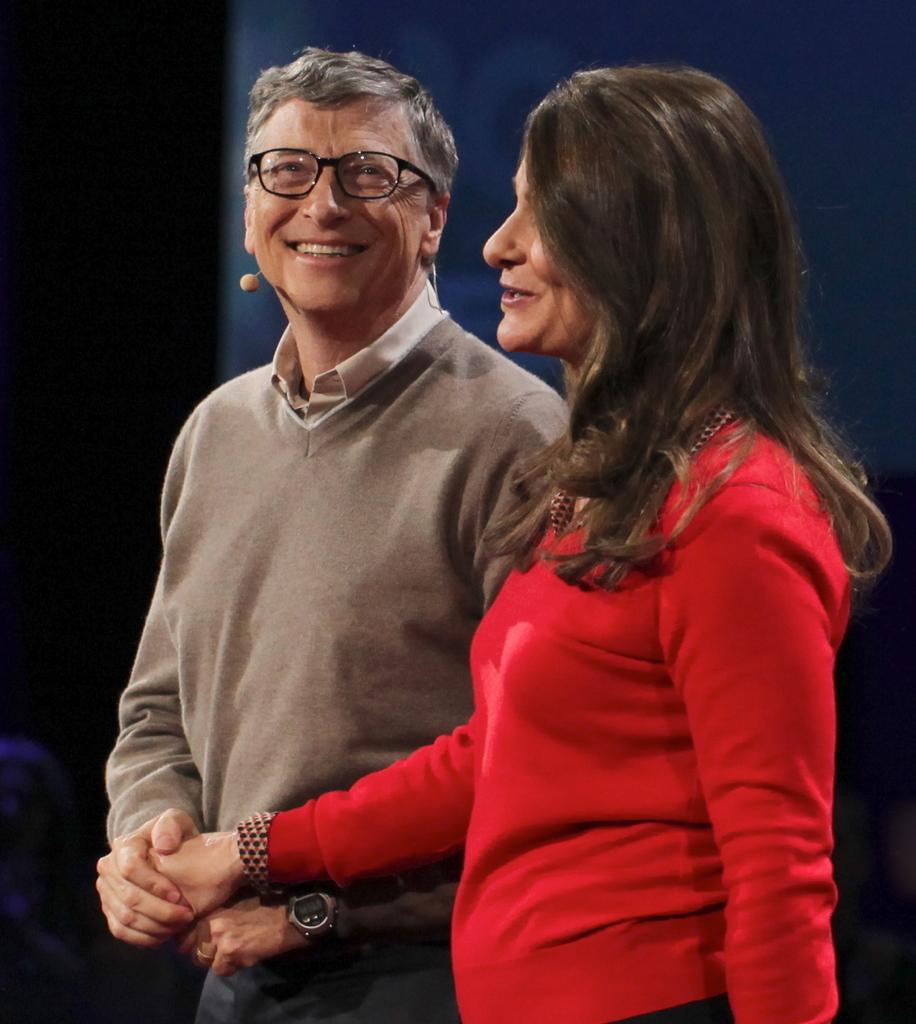Please provide a concise description of this image. In this image, we can see two people standing and there is a dark background. 